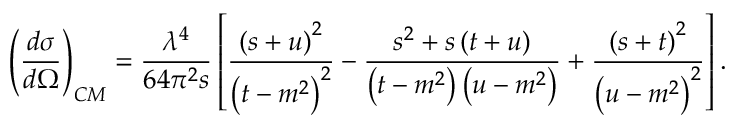<formula> <loc_0><loc_0><loc_500><loc_500>\left ( \frac { d \sigma } { d \Omega } \right ) _ { C M } = \frac { \lambda ^ { 4 } } { 6 4 \pi ^ { 2 } s } \left [ \frac { \left ( s + u \right ) ^ { 2 } } { \left ( t - m ^ { 2 } \right ) ^ { 2 } } - \frac { s ^ { 2 } + s \left ( t + u \right ) } { \left ( t - m ^ { 2 } \right ) \left ( u - m ^ { 2 } \right ) } + \frac { \left ( s + t \right ) ^ { 2 } } { \left ( u - m ^ { 2 } \right ) ^ { 2 } } \right ] .</formula> 